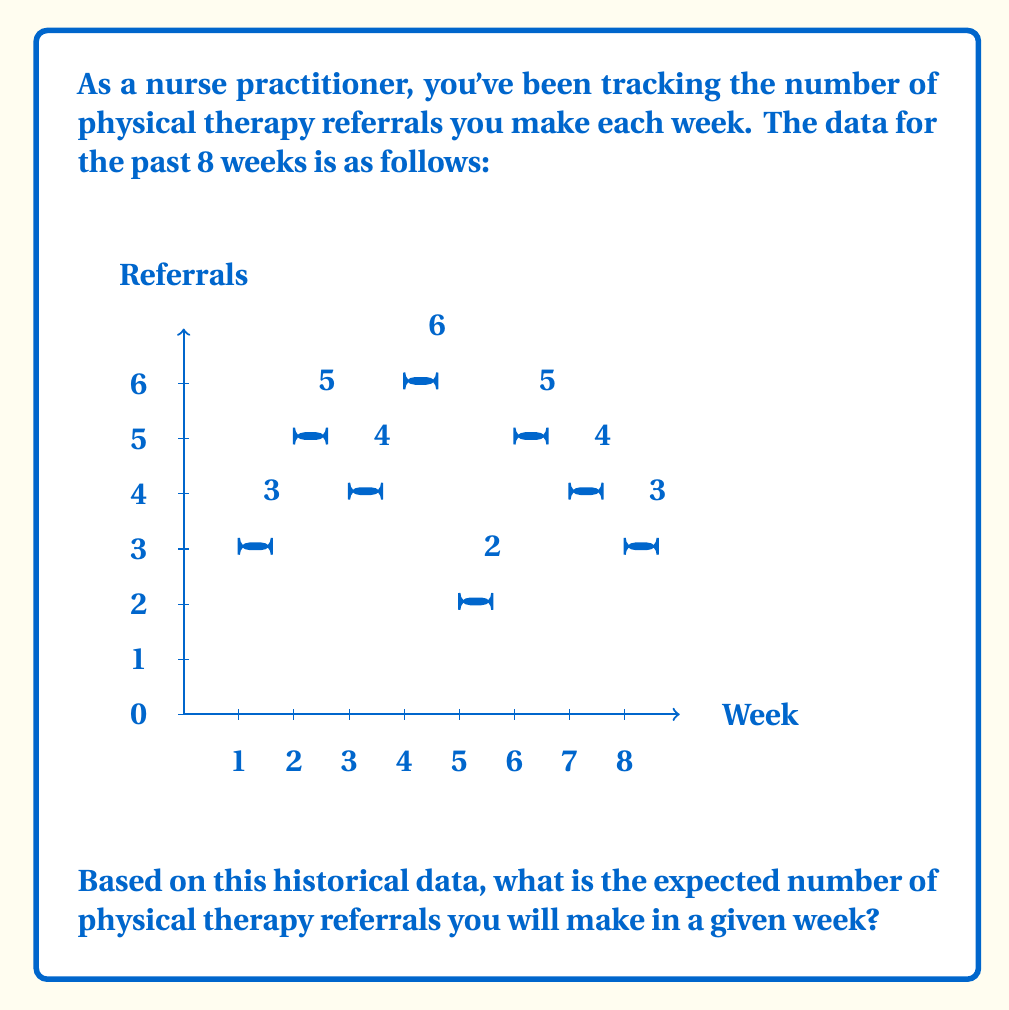Help me with this question. To find the expected number of physical therapy referrals per week, we need to calculate the mean (average) of the historical data. Here's how we do it:

1) First, let's sum up all the referrals:
   $3 + 5 + 4 + 6 + 2 + 5 + 4 + 3 = 32$ total referrals

2) Now, we need to divide this sum by the number of weeks (8):

   $\text{Expected number} = \frac{\text{Total referrals}}{\text{Number of weeks}} = \frac{32}{8} = 4$

3) We can express this mathematically as:

   $$E(X) = \frac{1}{n}\sum_{i=1}^n x_i$$

   Where $E(X)$ is the expected value, $n$ is the number of weeks, and $x_i$ are the individual weekly referral counts.

4) Plugging in our values:

   $$E(X) = \frac{1}{8}(3+5+4+6+2+5+4+3) = \frac{32}{8} = 4$$

Therefore, based on this historical data, you can expect to make 4 physical therapy referrals in a given week.
Answer: 4 referrals 